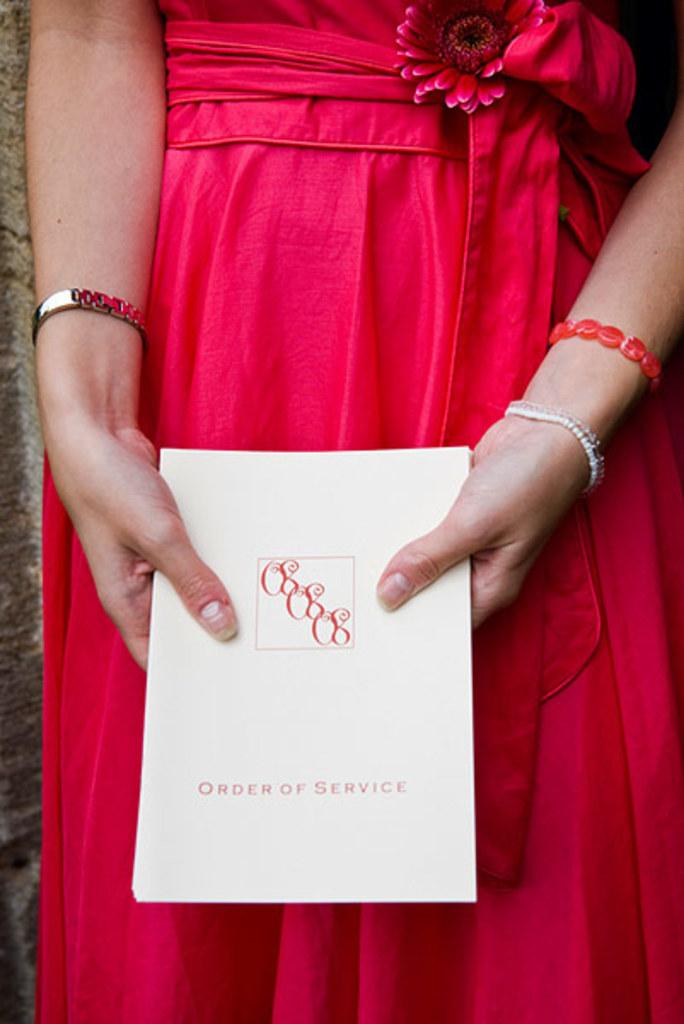What is the person in the image wearing? The person is wearing a pink dress. What is the person holding in the image? The person is holding a card with text on it. What color is the flower in the image? The flower in the image is pink. What type of accessory is visible on the person's wrist? A watch and a bracelet are visible in the image. How many birds are in the flock that is visible in the image? There are no birds or flocks present in the image. 